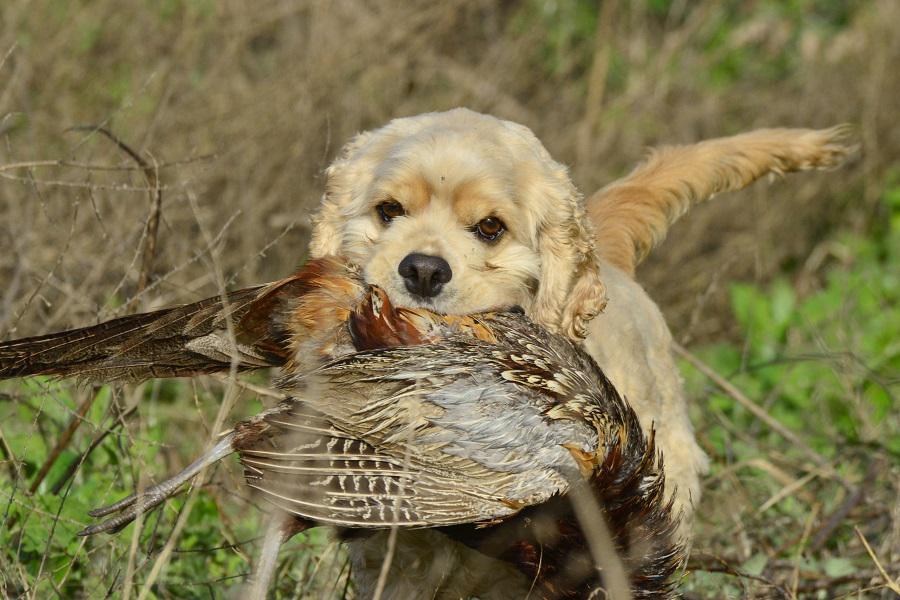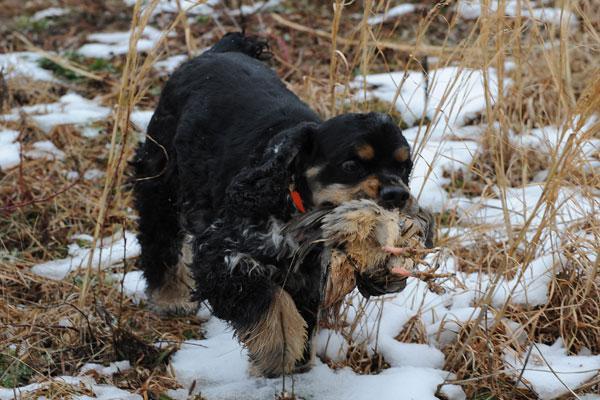The first image is the image on the left, the second image is the image on the right. Given the left and right images, does the statement "Each image shows a spaniel carrying a bird in its mouth across the ground." hold true? Answer yes or no. Yes. The first image is the image on the left, the second image is the image on the right. Evaluate the accuracy of this statement regarding the images: "Each image shows a dog on dry land carrying a bird in its mouth.". Is it true? Answer yes or no. Yes. 